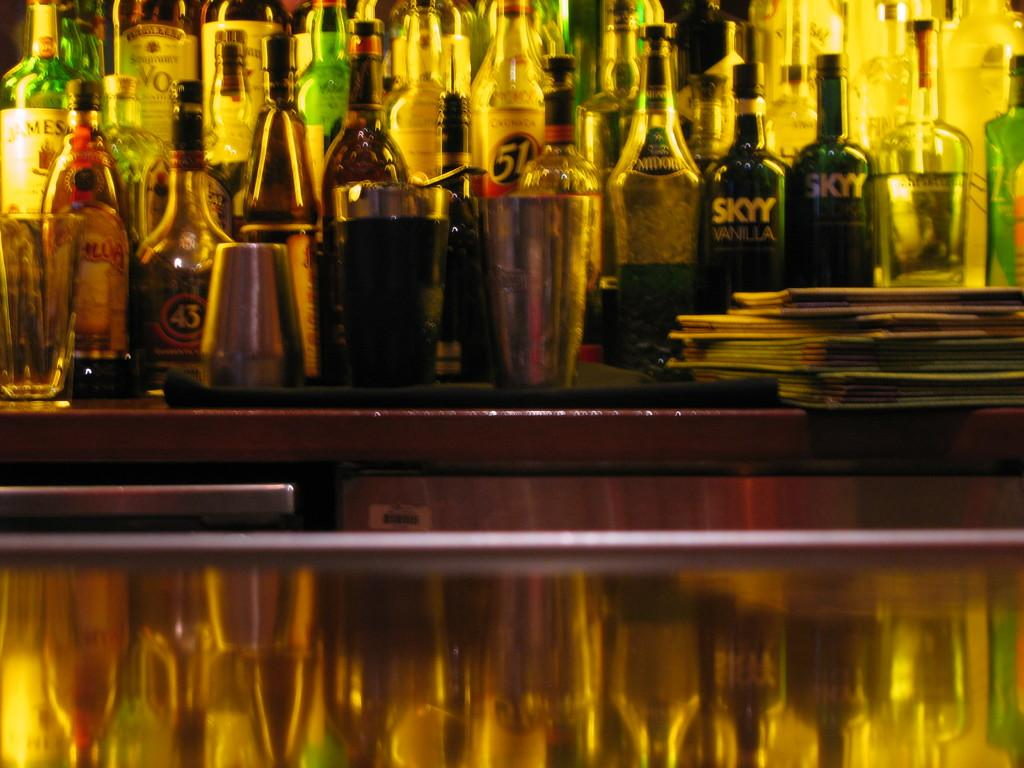<image>
Describe the image concisely. A bunch of liquor bottles and some are by SKYY vodka 